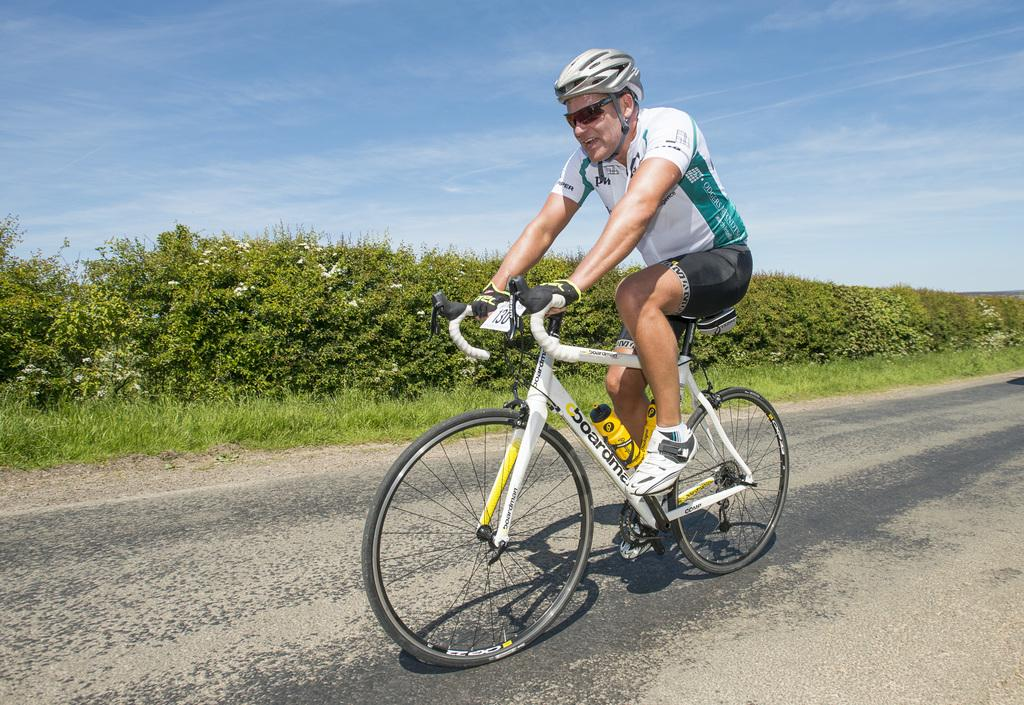Who is the main subject in the image? There is a man in the image. What is the man doing in the image? The man is on a bicycle. Where is the man located in the image? The man is in the center of the image. What can be seen in the background of the image? There is greenery in the background of the image. What is visible at the top of the image? The sky is visible at the top of the image. What type of chicken is the man holding in the image? There is no chicken present in the image; the man is on a bicycle. Where did the man go on vacation, as seen in the image? The image does not show the man on vacation; it shows him riding a bicycle. 